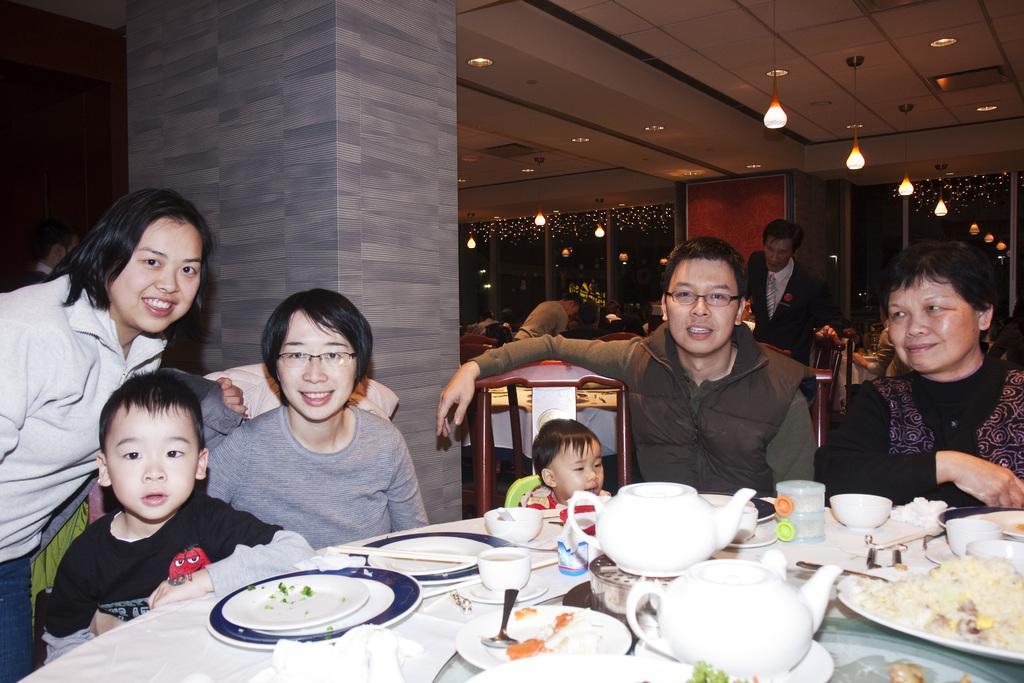Please provide a concise description of this image. This picture describes about group of people, few are seated on the chair and few are standing, in front of them we can find couple of plates, bowls, cups, spoons and some food on the table, in the background we can see a plant and couple of lights. 